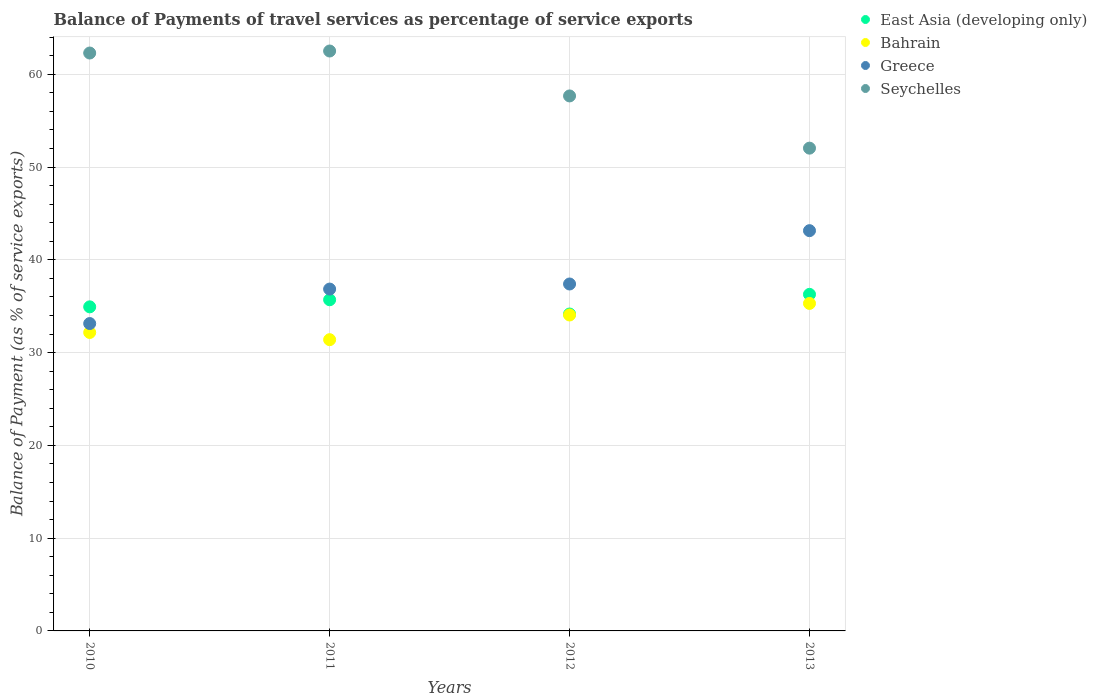Is the number of dotlines equal to the number of legend labels?
Your answer should be compact. Yes. What is the balance of payments of travel services in Seychelles in 2012?
Make the answer very short. 57.66. Across all years, what is the maximum balance of payments of travel services in Greece?
Your answer should be compact. 43.14. Across all years, what is the minimum balance of payments of travel services in East Asia (developing only)?
Ensure brevity in your answer.  34.16. In which year was the balance of payments of travel services in Greece minimum?
Give a very brief answer. 2010. What is the total balance of payments of travel services in East Asia (developing only) in the graph?
Offer a very short reply. 141.06. What is the difference between the balance of payments of travel services in East Asia (developing only) in 2010 and that in 2011?
Ensure brevity in your answer.  -0.76. What is the difference between the balance of payments of travel services in East Asia (developing only) in 2013 and the balance of payments of travel services in Bahrain in 2012?
Keep it short and to the point. 2.23. What is the average balance of payments of travel services in Greece per year?
Offer a very short reply. 37.63. In the year 2011, what is the difference between the balance of payments of travel services in Bahrain and balance of payments of travel services in Seychelles?
Offer a very short reply. -31.11. What is the ratio of the balance of payments of travel services in Bahrain in 2011 to that in 2012?
Provide a succinct answer. 0.92. Is the difference between the balance of payments of travel services in Bahrain in 2011 and 2012 greater than the difference between the balance of payments of travel services in Seychelles in 2011 and 2012?
Give a very brief answer. No. What is the difference between the highest and the second highest balance of payments of travel services in Seychelles?
Provide a succinct answer. 0.22. What is the difference between the highest and the lowest balance of payments of travel services in Bahrain?
Your answer should be very brief. 3.91. Is the sum of the balance of payments of travel services in Seychelles in 2010 and 2013 greater than the maximum balance of payments of travel services in East Asia (developing only) across all years?
Provide a succinct answer. Yes. Is it the case that in every year, the sum of the balance of payments of travel services in Bahrain and balance of payments of travel services in Seychelles  is greater than the sum of balance of payments of travel services in East Asia (developing only) and balance of payments of travel services in Greece?
Your response must be concise. No. Is it the case that in every year, the sum of the balance of payments of travel services in Bahrain and balance of payments of travel services in East Asia (developing only)  is greater than the balance of payments of travel services in Greece?
Provide a short and direct response. Yes. Does the balance of payments of travel services in Bahrain monotonically increase over the years?
Make the answer very short. No. Is the balance of payments of travel services in East Asia (developing only) strictly greater than the balance of payments of travel services in Bahrain over the years?
Your answer should be compact. Yes. What is the difference between two consecutive major ticks on the Y-axis?
Your answer should be compact. 10. Are the values on the major ticks of Y-axis written in scientific E-notation?
Your answer should be compact. No. What is the title of the graph?
Provide a succinct answer. Balance of Payments of travel services as percentage of service exports. Does "Liberia" appear as one of the legend labels in the graph?
Ensure brevity in your answer.  No. What is the label or title of the X-axis?
Provide a short and direct response. Years. What is the label or title of the Y-axis?
Keep it short and to the point. Balance of Payment (as % of service exports). What is the Balance of Payment (as % of service exports) of East Asia (developing only) in 2010?
Your response must be concise. 34.93. What is the Balance of Payment (as % of service exports) of Bahrain in 2010?
Your answer should be compact. 32.17. What is the Balance of Payment (as % of service exports) in Greece in 2010?
Keep it short and to the point. 33.13. What is the Balance of Payment (as % of service exports) in Seychelles in 2010?
Provide a succinct answer. 62.29. What is the Balance of Payment (as % of service exports) of East Asia (developing only) in 2011?
Make the answer very short. 35.69. What is the Balance of Payment (as % of service exports) of Bahrain in 2011?
Your answer should be compact. 31.39. What is the Balance of Payment (as % of service exports) in Greece in 2011?
Provide a succinct answer. 36.85. What is the Balance of Payment (as % of service exports) of Seychelles in 2011?
Ensure brevity in your answer.  62.51. What is the Balance of Payment (as % of service exports) of East Asia (developing only) in 2012?
Offer a very short reply. 34.16. What is the Balance of Payment (as % of service exports) of Bahrain in 2012?
Provide a succinct answer. 34.05. What is the Balance of Payment (as % of service exports) in Greece in 2012?
Provide a succinct answer. 37.39. What is the Balance of Payment (as % of service exports) in Seychelles in 2012?
Keep it short and to the point. 57.66. What is the Balance of Payment (as % of service exports) in East Asia (developing only) in 2013?
Provide a short and direct response. 36.28. What is the Balance of Payment (as % of service exports) in Bahrain in 2013?
Offer a terse response. 35.3. What is the Balance of Payment (as % of service exports) in Greece in 2013?
Provide a succinct answer. 43.14. What is the Balance of Payment (as % of service exports) in Seychelles in 2013?
Your answer should be very brief. 52.04. Across all years, what is the maximum Balance of Payment (as % of service exports) of East Asia (developing only)?
Provide a succinct answer. 36.28. Across all years, what is the maximum Balance of Payment (as % of service exports) in Bahrain?
Provide a succinct answer. 35.3. Across all years, what is the maximum Balance of Payment (as % of service exports) in Greece?
Provide a short and direct response. 43.14. Across all years, what is the maximum Balance of Payment (as % of service exports) in Seychelles?
Provide a succinct answer. 62.51. Across all years, what is the minimum Balance of Payment (as % of service exports) in East Asia (developing only)?
Provide a succinct answer. 34.16. Across all years, what is the minimum Balance of Payment (as % of service exports) of Bahrain?
Your answer should be very brief. 31.39. Across all years, what is the minimum Balance of Payment (as % of service exports) in Greece?
Offer a very short reply. 33.13. Across all years, what is the minimum Balance of Payment (as % of service exports) in Seychelles?
Make the answer very short. 52.04. What is the total Balance of Payment (as % of service exports) in East Asia (developing only) in the graph?
Your response must be concise. 141.06. What is the total Balance of Payment (as % of service exports) in Bahrain in the graph?
Your response must be concise. 132.91. What is the total Balance of Payment (as % of service exports) in Greece in the graph?
Your answer should be compact. 150.51. What is the total Balance of Payment (as % of service exports) of Seychelles in the graph?
Your answer should be compact. 234.49. What is the difference between the Balance of Payment (as % of service exports) of East Asia (developing only) in 2010 and that in 2011?
Your response must be concise. -0.76. What is the difference between the Balance of Payment (as % of service exports) of Bahrain in 2010 and that in 2011?
Make the answer very short. 0.78. What is the difference between the Balance of Payment (as % of service exports) in Greece in 2010 and that in 2011?
Your answer should be compact. -3.72. What is the difference between the Balance of Payment (as % of service exports) of Seychelles in 2010 and that in 2011?
Your response must be concise. -0.22. What is the difference between the Balance of Payment (as % of service exports) of East Asia (developing only) in 2010 and that in 2012?
Offer a terse response. 0.77. What is the difference between the Balance of Payment (as % of service exports) in Bahrain in 2010 and that in 2012?
Provide a short and direct response. -1.88. What is the difference between the Balance of Payment (as % of service exports) in Greece in 2010 and that in 2012?
Offer a terse response. -4.26. What is the difference between the Balance of Payment (as % of service exports) in Seychelles in 2010 and that in 2012?
Provide a short and direct response. 4.63. What is the difference between the Balance of Payment (as % of service exports) of East Asia (developing only) in 2010 and that in 2013?
Your answer should be very brief. -1.35. What is the difference between the Balance of Payment (as % of service exports) in Bahrain in 2010 and that in 2013?
Your response must be concise. -3.13. What is the difference between the Balance of Payment (as % of service exports) of Greece in 2010 and that in 2013?
Offer a terse response. -10.01. What is the difference between the Balance of Payment (as % of service exports) of Seychelles in 2010 and that in 2013?
Offer a very short reply. 10.25. What is the difference between the Balance of Payment (as % of service exports) of East Asia (developing only) in 2011 and that in 2012?
Make the answer very short. 1.54. What is the difference between the Balance of Payment (as % of service exports) in Bahrain in 2011 and that in 2012?
Your response must be concise. -2.66. What is the difference between the Balance of Payment (as % of service exports) of Greece in 2011 and that in 2012?
Make the answer very short. -0.55. What is the difference between the Balance of Payment (as % of service exports) in Seychelles in 2011 and that in 2012?
Provide a succinct answer. 4.84. What is the difference between the Balance of Payment (as % of service exports) of East Asia (developing only) in 2011 and that in 2013?
Ensure brevity in your answer.  -0.58. What is the difference between the Balance of Payment (as % of service exports) in Bahrain in 2011 and that in 2013?
Keep it short and to the point. -3.91. What is the difference between the Balance of Payment (as % of service exports) of Greece in 2011 and that in 2013?
Keep it short and to the point. -6.3. What is the difference between the Balance of Payment (as % of service exports) in Seychelles in 2011 and that in 2013?
Offer a terse response. 10.47. What is the difference between the Balance of Payment (as % of service exports) of East Asia (developing only) in 2012 and that in 2013?
Provide a short and direct response. -2.12. What is the difference between the Balance of Payment (as % of service exports) in Bahrain in 2012 and that in 2013?
Your answer should be very brief. -1.25. What is the difference between the Balance of Payment (as % of service exports) of Greece in 2012 and that in 2013?
Provide a succinct answer. -5.75. What is the difference between the Balance of Payment (as % of service exports) of Seychelles in 2012 and that in 2013?
Offer a terse response. 5.63. What is the difference between the Balance of Payment (as % of service exports) of East Asia (developing only) in 2010 and the Balance of Payment (as % of service exports) of Bahrain in 2011?
Keep it short and to the point. 3.54. What is the difference between the Balance of Payment (as % of service exports) in East Asia (developing only) in 2010 and the Balance of Payment (as % of service exports) in Greece in 2011?
Ensure brevity in your answer.  -1.92. What is the difference between the Balance of Payment (as % of service exports) in East Asia (developing only) in 2010 and the Balance of Payment (as % of service exports) in Seychelles in 2011?
Your answer should be very brief. -27.58. What is the difference between the Balance of Payment (as % of service exports) in Bahrain in 2010 and the Balance of Payment (as % of service exports) in Greece in 2011?
Offer a very short reply. -4.68. What is the difference between the Balance of Payment (as % of service exports) of Bahrain in 2010 and the Balance of Payment (as % of service exports) of Seychelles in 2011?
Offer a terse response. -30.34. What is the difference between the Balance of Payment (as % of service exports) in Greece in 2010 and the Balance of Payment (as % of service exports) in Seychelles in 2011?
Your response must be concise. -29.38. What is the difference between the Balance of Payment (as % of service exports) of East Asia (developing only) in 2010 and the Balance of Payment (as % of service exports) of Bahrain in 2012?
Your answer should be very brief. 0.88. What is the difference between the Balance of Payment (as % of service exports) in East Asia (developing only) in 2010 and the Balance of Payment (as % of service exports) in Greece in 2012?
Provide a succinct answer. -2.46. What is the difference between the Balance of Payment (as % of service exports) in East Asia (developing only) in 2010 and the Balance of Payment (as % of service exports) in Seychelles in 2012?
Keep it short and to the point. -22.73. What is the difference between the Balance of Payment (as % of service exports) of Bahrain in 2010 and the Balance of Payment (as % of service exports) of Greece in 2012?
Provide a short and direct response. -5.23. What is the difference between the Balance of Payment (as % of service exports) of Bahrain in 2010 and the Balance of Payment (as % of service exports) of Seychelles in 2012?
Offer a terse response. -25.5. What is the difference between the Balance of Payment (as % of service exports) in Greece in 2010 and the Balance of Payment (as % of service exports) in Seychelles in 2012?
Make the answer very short. -24.53. What is the difference between the Balance of Payment (as % of service exports) of East Asia (developing only) in 2010 and the Balance of Payment (as % of service exports) of Bahrain in 2013?
Keep it short and to the point. -0.37. What is the difference between the Balance of Payment (as % of service exports) in East Asia (developing only) in 2010 and the Balance of Payment (as % of service exports) in Greece in 2013?
Offer a terse response. -8.21. What is the difference between the Balance of Payment (as % of service exports) in East Asia (developing only) in 2010 and the Balance of Payment (as % of service exports) in Seychelles in 2013?
Ensure brevity in your answer.  -17.11. What is the difference between the Balance of Payment (as % of service exports) in Bahrain in 2010 and the Balance of Payment (as % of service exports) in Greece in 2013?
Make the answer very short. -10.97. What is the difference between the Balance of Payment (as % of service exports) in Bahrain in 2010 and the Balance of Payment (as % of service exports) in Seychelles in 2013?
Provide a succinct answer. -19.87. What is the difference between the Balance of Payment (as % of service exports) in Greece in 2010 and the Balance of Payment (as % of service exports) in Seychelles in 2013?
Provide a short and direct response. -18.91. What is the difference between the Balance of Payment (as % of service exports) of East Asia (developing only) in 2011 and the Balance of Payment (as % of service exports) of Bahrain in 2012?
Give a very brief answer. 1.64. What is the difference between the Balance of Payment (as % of service exports) of East Asia (developing only) in 2011 and the Balance of Payment (as % of service exports) of Greece in 2012?
Offer a terse response. -1.7. What is the difference between the Balance of Payment (as % of service exports) in East Asia (developing only) in 2011 and the Balance of Payment (as % of service exports) in Seychelles in 2012?
Your answer should be compact. -21.97. What is the difference between the Balance of Payment (as % of service exports) of Bahrain in 2011 and the Balance of Payment (as % of service exports) of Greece in 2012?
Keep it short and to the point. -6. What is the difference between the Balance of Payment (as % of service exports) in Bahrain in 2011 and the Balance of Payment (as % of service exports) in Seychelles in 2012?
Your response must be concise. -26.27. What is the difference between the Balance of Payment (as % of service exports) in Greece in 2011 and the Balance of Payment (as % of service exports) in Seychelles in 2012?
Your answer should be very brief. -20.82. What is the difference between the Balance of Payment (as % of service exports) of East Asia (developing only) in 2011 and the Balance of Payment (as % of service exports) of Bahrain in 2013?
Your response must be concise. 0.39. What is the difference between the Balance of Payment (as % of service exports) of East Asia (developing only) in 2011 and the Balance of Payment (as % of service exports) of Greece in 2013?
Provide a short and direct response. -7.45. What is the difference between the Balance of Payment (as % of service exports) in East Asia (developing only) in 2011 and the Balance of Payment (as % of service exports) in Seychelles in 2013?
Offer a very short reply. -16.34. What is the difference between the Balance of Payment (as % of service exports) of Bahrain in 2011 and the Balance of Payment (as % of service exports) of Greece in 2013?
Provide a succinct answer. -11.75. What is the difference between the Balance of Payment (as % of service exports) of Bahrain in 2011 and the Balance of Payment (as % of service exports) of Seychelles in 2013?
Provide a short and direct response. -20.64. What is the difference between the Balance of Payment (as % of service exports) of Greece in 2011 and the Balance of Payment (as % of service exports) of Seychelles in 2013?
Provide a succinct answer. -15.19. What is the difference between the Balance of Payment (as % of service exports) of East Asia (developing only) in 2012 and the Balance of Payment (as % of service exports) of Bahrain in 2013?
Keep it short and to the point. -1.14. What is the difference between the Balance of Payment (as % of service exports) of East Asia (developing only) in 2012 and the Balance of Payment (as % of service exports) of Greece in 2013?
Provide a short and direct response. -8.98. What is the difference between the Balance of Payment (as % of service exports) in East Asia (developing only) in 2012 and the Balance of Payment (as % of service exports) in Seychelles in 2013?
Keep it short and to the point. -17.88. What is the difference between the Balance of Payment (as % of service exports) in Bahrain in 2012 and the Balance of Payment (as % of service exports) in Greece in 2013?
Your answer should be very brief. -9.09. What is the difference between the Balance of Payment (as % of service exports) of Bahrain in 2012 and the Balance of Payment (as % of service exports) of Seychelles in 2013?
Offer a terse response. -17.98. What is the difference between the Balance of Payment (as % of service exports) in Greece in 2012 and the Balance of Payment (as % of service exports) in Seychelles in 2013?
Keep it short and to the point. -14.64. What is the average Balance of Payment (as % of service exports) in East Asia (developing only) per year?
Provide a short and direct response. 35.26. What is the average Balance of Payment (as % of service exports) in Bahrain per year?
Keep it short and to the point. 33.23. What is the average Balance of Payment (as % of service exports) of Greece per year?
Your answer should be compact. 37.63. What is the average Balance of Payment (as % of service exports) of Seychelles per year?
Make the answer very short. 58.62. In the year 2010, what is the difference between the Balance of Payment (as % of service exports) of East Asia (developing only) and Balance of Payment (as % of service exports) of Bahrain?
Keep it short and to the point. 2.76. In the year 2010, what is the difference between the Balance of Payment (as % of service exports) of East Asia (developing only) and Balance of Payment (as % of service exports) of Greece?
Ensure brevity in your answer.  1.8. In the year 2010, what is the difference between the Balance of Payment (as % of service exports) in East Asia (developing only) and Balance of Payment (as % of service exports) in Seychelles?
Your response must be concise. -27.36. In the year 2010, what is the difference between the Balance of Payment (as % of service exports) of Bahrain and Balance of Payment (as % of service exports) of Greece?
Provide a short and direct response. -0.96. In the year 2010, what is the difference between the Balance of Payment (as % of service exports) in Bahrain and Balance of Payment (as % of service exports) in Seychelles?
Provide a succinct answer. -30.12. In the year 2010, what is the difference between the Balance of Payment (as % of service exports) of Greece and Balance of Payment (as % of service exports) of Seychelles?
Your response must be concise. -29.16. In the year 2011, what is the difference between the Balance of Payment (as % of service exports) in East Asia (developing only) and Balance of Payment (as % of service exports) in Bahrain?
Make the answer very short. 4.3. In the year 2011, what is the difference between the Balance of Payment (as % of service exports) in East Asia (developing only) and Balance of Payment (as % of service exports) in Greece?
Ensure brevity in your answer.  -1.15. In the year 2011, what is the difference between the Balance of Payment (as % of service exports) in East Asia (developing only) and Balance of Payment (as % of service exports) in Seychelles?
Offer a terse response. -26.81. In the year 2011, what is the difference between the Balance of Payment (as % of service exports) of Bahrain and Balance of Payment (as % of service exports) of Greece?
Your answer should be very brief. -5.45. In the year 2011, what is the difference between the Balance of Payment (as % of service exports) of Bahrain and Balance of Payment (as % of service exports) of Seychelles?
Offer a terse response. -31.11. In the year 2011, what is the difference between the Balance of Payment (as % of service exports) of Greece and Balance of Payment (as % of service exports) of Seychelles?
Your response must be concise. -25.66. In the year 2012, what is the difference between the Balance of Payment (as % of service exports) of East Asia (developing only) and Balance of Payment (as % of service exports) of Bahrain?
Provide a short and direct response. 0.11. In the year 2012, what is the difference between the Balance of Payment (as % of service exports) in East Asia (developing only) and Balance of Payment (as % of service exports) in Greece?
Your response must be concise. -3.24. In the year 2012, what is the difference between the Balance of Payment (as % of service exports) of East Asia (developing only) and Balance of Payment (as % of service exports) of Seychelles?
Your answer should be compact. -23.51. In the year 2012, what is the difference between the Balance of Payment (as % of service exports) in Bahrain and Balance of Payment (as % of service exports) in Greece?
Your answer should be very brief. -3.34. In the year 2012, what is the difference between the Balance of Payment (as % of service exports) in Bahrain and Balance of Payment (as % of service exports) in Seychelles?
Make the answer very short. -23.61. In the year 2012, what is the difference between the Balance of Payment (as % of service exports) in Greece and Balance of Payment (as % of service exports) in Seychelles?
Offer a terse response. -20.27. In the year 2013, what is the difference between the Balance of Payment (as % of service exports) of East Asia (developing only) and Balance of Payment (as % of service exports) of Greece?
Offer a very short reply. -6.86. In the year 2013, what is the difference between the Balance of Payment (as % of service exports) in East Asia (developing only) and Balance of Payment (as % of service exports) in Seychelles?
Your answer should be very brief. -15.76. In the year 2013, what is the difference between the Balance of Payment (as % of service exports) in Bahrain and Balance of Payment (as % of service exports) in Greece?
Offer a very short reply. -7.84. In the year 2013, what is the difference between the Balance of Payment (as % of service exports) of Bahrain and Balance of Payment (as % of service exports) of Seychelles?
Provide a succinct answer. -16.74. In the year 2013, what is the difference between the Balance of Payment (as % of service exports) in Greece and Balance of Payment (as % of service exports) in Seychelles?
Your response must be concise. -8.89. What is the ratio of the Balance of Payment (as % of service exports) in East Asia (developing only) in 2010 to that in 2011?
Your response must be concise. 0.98. What is the ratio of the Balance of Payment (as % of service exports) of Bahrain in 2010 to that in 2011?
Ensure brevity in your answer.  1.02. What is the ratio of the Balance of Payment (as % of service exports) of Greece in 2010 to that in 2011?
Offer a very short reply. 0.9. What is the ratio of the Balance of Payment (as % of service exports) of Seychelles in 2010 to that in 2011?
Give a very brief answer. 1. What is the ratio of the Balance of Payment (as % of service exports) in East Asia (developing only) in 2010 to that in 2012?
Offer a very short reply. 1.02. What is the ratio of the Balance of Payment (as % of service exports) of Bahrain in 2010 to that in 2012?
Provide a short and direct response. 0.94. What is the ratio of the Balance of Payment (as % of service exports) in Greece in 2010 to that in 2012?
Your answer should be compact. 0.89. What is the ratio of the Balance of Payment (as % of service exports) of Seychelles in 2010 to that in 2012?
Your answer should be compact. 1.08. What is the ratio of the Balance of Payment (as % of service exports) of East Asia (developing only) in 2010 to that in 2013?
Make the answer very short. 0.96. What is the ratio of the Balance of Payment (as % of service exports) in Bahrain in 2010 to that in 2013?
Your response must be concise. 0.91. What is the ratio of the Balance of Payment (as % of service exports) in Greece in 2010 to that in 2013?
Your answer should be very brief. 0.77. What is the ratio of the Balance of Payment (as % of service exports) in Seychelles in 2010 to that in 2013?
Make the answer very short. 1.2. What is the ratio of the Balance of Payment (as % of service exports) in East Asia (developing only) in 2011 to that in 2012?
Keep it short and to the point. 1.04. What is the ratio of the Balance of Payment (as % of service exports) of Bahrain in 2011 to that in 2012?
Give a very brief answer. 0.92. What is the ratio of the Balance of Payment (as % of service exports) in Greece in 2011 to that in 2012?
Your answer should be compact. 0.99. What is the ratio of the Balance of Payment (as % of service exports) in Seychelles in 2011 to that in 2012?
Offer a very short reply. 1.08. What is the ratio of the Balance of Payment (as % of service exports) of East Asia (developing only) in 2011 to that in 2013?
Provide a short and direct response. 0.98. What is the ratio of the Balance of Payment (as % of service exports) of Bahrain in 2011 to that in 2013?
Offer a terse response. 0.89. What is the ratio of the Balance of Payment (as % of service exports) in Greece in 2011 to that in 2013?
Give a very brief answer. 0.85. What is the ratio of the Balance of Payment (as % of service exports) in Seychelles in 2011 to that in 2013?
Your response must be concise. 1.2. What is the ratio of the Balance of Payment (as % of service exports) of East Asia (developing only) in 2012 to that in 2013?
Give a very brief answer. 0.94. What is the ratio of the Balance of Payment (as % of service exports) in Bahrain in 2012 to that in 2013?
Your answer should be compact. 0.96. What is the ratio of the Balance of Payment (as % of service exports) in Greece in 2012 to that in 2013?
Offer a very short reply. 0.87. What is the ratio of the Balance of Payment (as % of service exports) of Seychelles in 2012 to that in 2013?
Your response must be concise. 1.11. What is the difference between the highest and the second highest Balance of Payment (as % of service exports) in East Asia (developing only)?
Your answer should be very brief. 0.58. What is the difference between the highest and the second highest Balance of Payment (as % of service exports) in Bahrain?
Offer a terse response. 1.25. What is the difference between the highest and the second highest Balance of Payment (as % of service exports) in Greece?
Offer a very short reply. 5.75. What is the difference between the highest and the second highest Balance of Payment (as % of service exports) in Seychelles?
Give a very brief answer. 0.22. What is the difference between the highest and the lowest Balance of Payment (as % of service exports) of East Asia (developing only)?
Your answer should be compact. 2.12. What is the difference between the highest and the lowest Balance of Payment (as % of service exports) in Bahrain?
Your answer should be very brief. 3.91. What is the difference between the highest and the lowest Balance of Payment (as % of service exports) in Greece?
Provide a succinct answer. 10.01. What is the difference between the highest and the lowest Balance of Payment (as % of service exports) of Seychelles?
Provide a short and direct response. 10.47. 